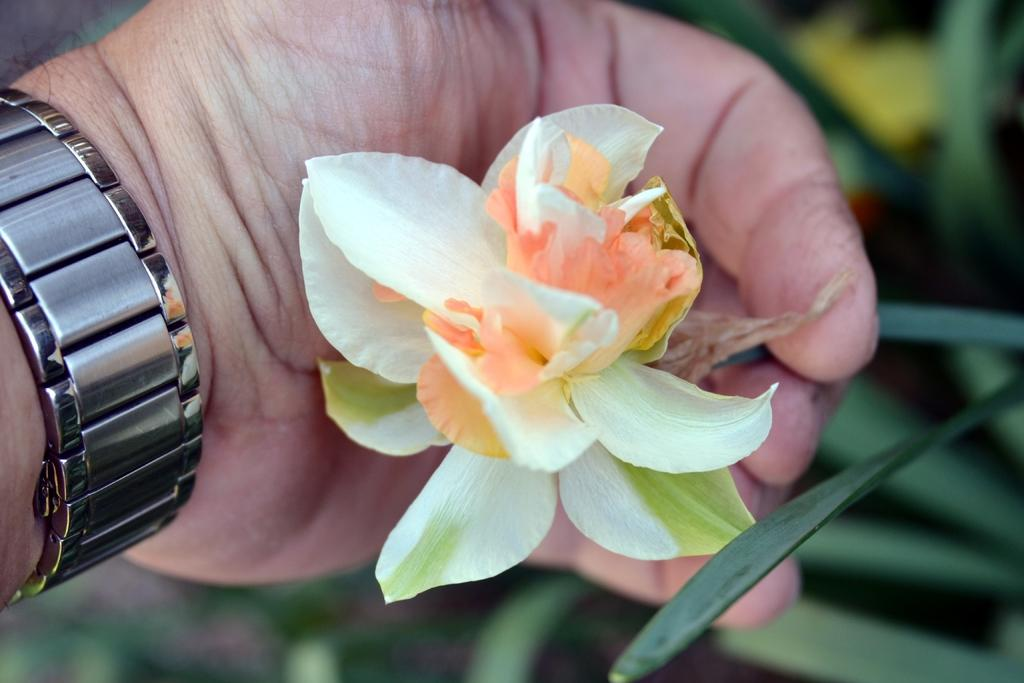Who or what is the main subject in the image? There is a person in the image. What is the person holding in the image? The person is holding a flower. Can you describe any accessories the person is wearing? There is a watch on the person's hand. How would you describe the background of the image? The background of the image is blurred. What type of vegetation can be seen in the image? Leaves are present in the image. What type of oatmeal is being served on the person's plate in the image? There is no plate or oatmeal present in the image; the person is holding a flower and wearing a watch. 